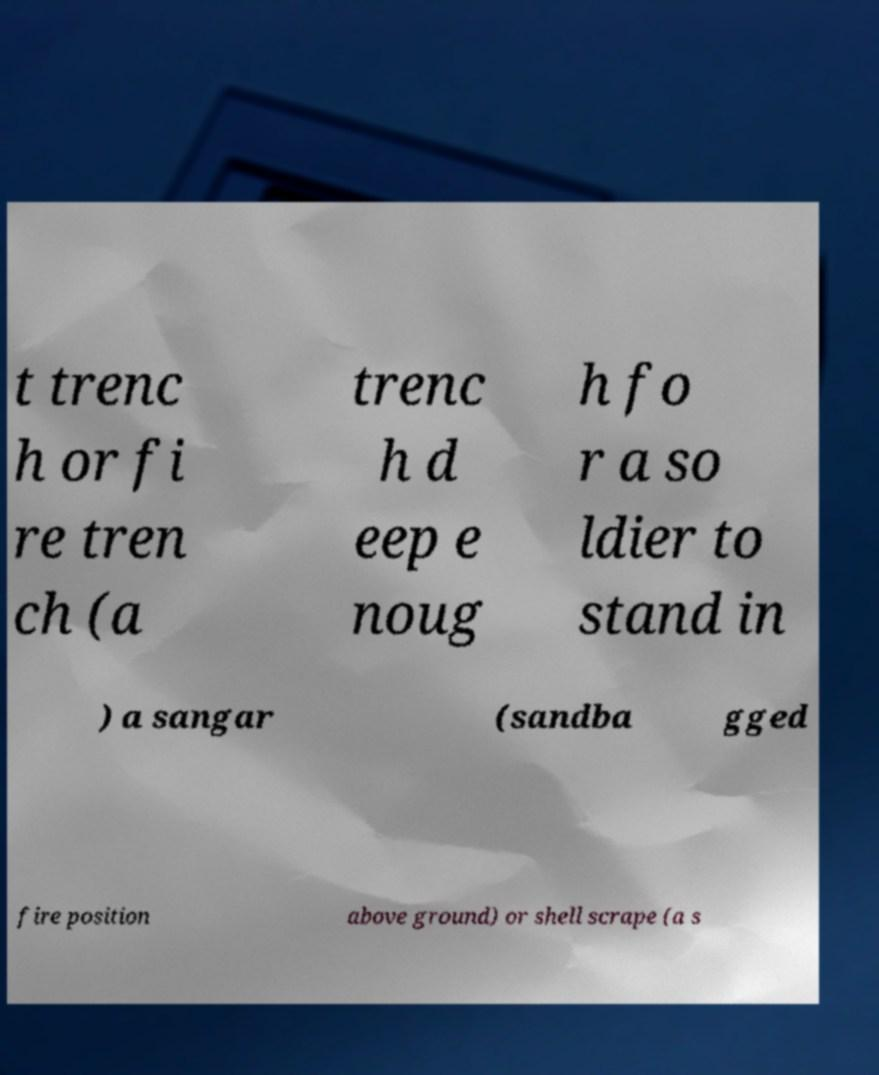There's text embedded in this image that I need extracted. Can you transcribe it verbatim? t trenc h or fi re tren ch (a trenc h d eep e noug h fo r a so ldier to stand in ) a sangar (sandba gged fire position above ground) or shell scrape (a s 